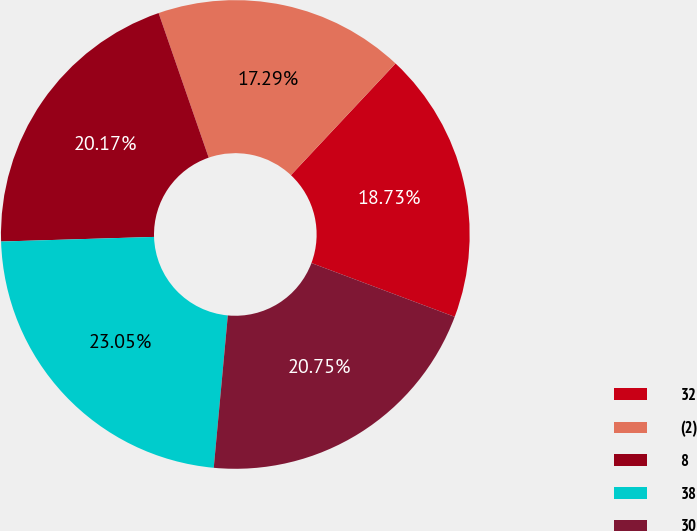<chart> <loc_0><loc_0><loc_500><loc_500><pie_chart><fcel>32<fcel>(2)<fcel>8<fcel>38<fcel>30<nl><fcel>18.73%<fcel>17.29%<fcel>20.17%<fcel>23.05%<fcel>20.75%<nl></chart> 